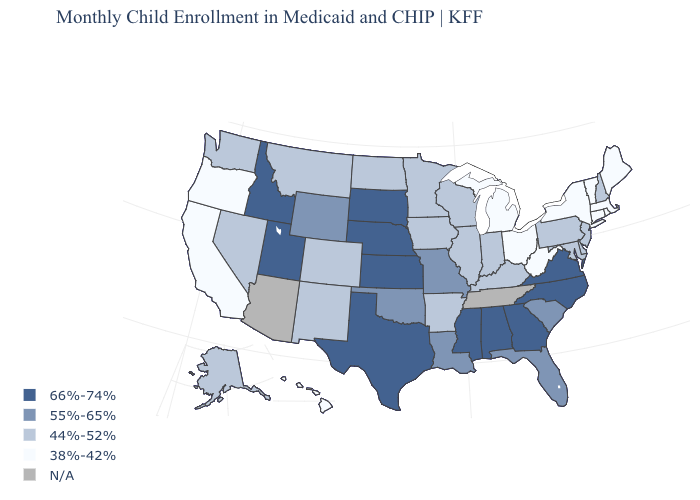Name the states that have a value in the range 38%-42%?
Keep it brief. California, Connecticut, Hawaii, Maine, Massachusetts, Michigan, New York, Ohio, Oregon, Rhode Island, Vermont, West Virginia. What is the value of Florida?
Answer briefly. 55%-65%. What is the highest value in the USA?
Concise answer only. 66%-74%. What is the value of Kentucky?
Concise answer only. 44%-52%. Name the states that have a value in the range 44%-52%?
Quick response, please. Alaska, Arkansas, Colorado, Delaware, Illinois, Indiana, Iowa, Kentucky, Maryland, Minnesota, Montana, Nevada, New Hampshire, New Jersey, New Mexico, North Dakota, Pennsylvania, Washington, Wisconsin. Does the map have missing data?
Write a very short answer. Yes. Does New Hampshire have the lowest value in the USA?
Write a very short answer. No. Name the states that have a value in the range N/A?
Be succinct. Arizona, Tennessee. Name the states that have a value in the range 44%-52%?
Concise answer only. Alaska, Arkansas, Colorado, Delaware, Illinois, Indiana, Iowa, Kentucky, Maryland, Minnesota, Montana, Nevada, New Hampshire, New Jersey, New Mexico, North Dakota, Pennsylvania, Washington, Wisconsin. Which states hav the highest value in the West?
Short answer required. Idaho, Utah. Which states hav the highest value in the South?
Quick response, please. Alabama, Georgia, Mississippi, North Carolina, Texas, Virginia. Among the states that border Wyoming , which have the lowest value?
Write a very short answer. Colorado, Montana. Among the states that border Montana , does North Dakota have the highest value?
Short answer required. No. Does Minnesota have the highest value in the MidWest?
Be succinct. No. Is the legend a continuous bar?
Short answer required. No. 